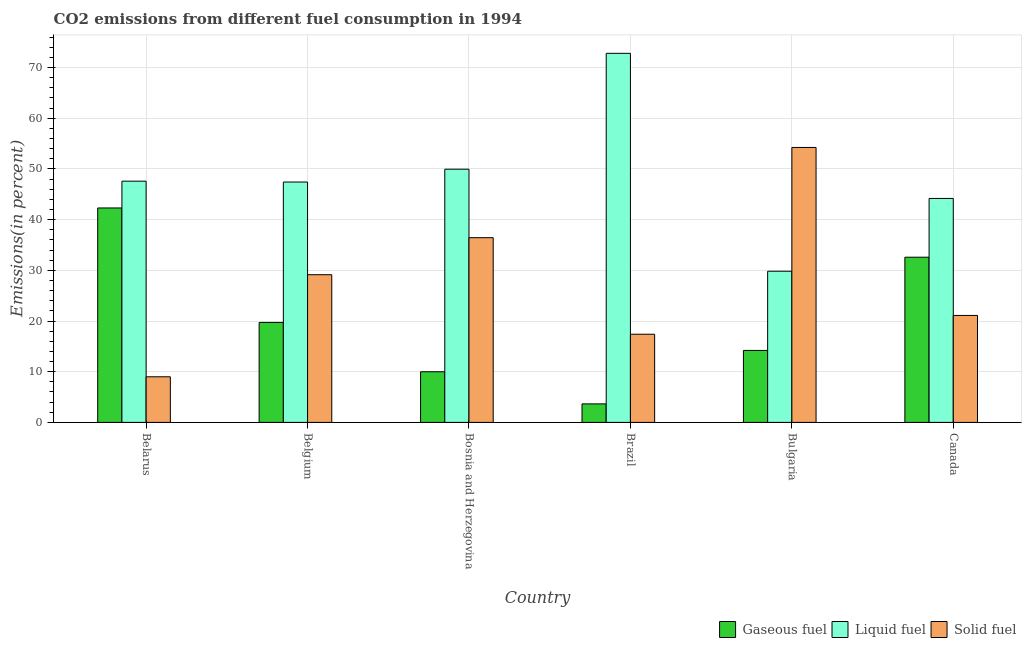How many groups of bars are there?
Provide a succinct answer. 6. Are the number of bars on each tick of the X-axis equal?
Your response must be concise. Yes. How many bars are there on the 3rd tick from the left?
Your response must be concise. 3. How many bars are there on the 3rd tick from the right?
Give a very brief answer. 3. What is the label of the 3rd group of bars from the left?
Offer a very short reply. Bosnia and Herzegovina. What is the percentage of liquid fuel emission in Bulgaria?
Give a very brief answer. 29.82. Across all countries, what is the maximum percentage of gaseous fuel emission?
Offer a terse response. 42.3. Across all countries, what is the minimum percentage of liquid fuel emission?
Provide a succinct answer. 29.82. In which country was the percentage of gaseous fuel emission maximum?
Offer a terse response. Belarus. In which country was the percentage of liquid fuel emission minimum?
Your answer should be compact. Bulgaria. What is the total percentage of solid fuel emission in the graph?
Your answer should be compact. 167.28. What is the difference between the percentage of solid fuel emission in Bulgaria and that in Canada?
Your answer should be very brief. 33.13. What is the difference between the percentage of gaseous fuel emission in Canada and the percentage of solid fuel emission in Bosnia and Herzegovina?
Your answer should be very brief. -3.85. What is the average percentage of gaseous fuel emission per country?
Offer a terse response. 20.41. What is the difference between the percentage of solid fuel emission and percentage of liquid fuel emission in Bulgaria?
Your response must be concise. 24.41. In how many countries, is the percentage of gaseous fuel emission greater than 36 %?
Ensure brevity in your answer.  1. What is the ratio of the percentage of liquid fuel emission in Belarus to that in Bulgaria?
Your response must be concise. 1.6. What is the difference between the highest and the second highest percentage of gaseous fuel emission?
Your response must be concise. 9.71. What is the difference between the highest and the lowest percentage of liquid fuel emission?
Your answer should be very brief. 42.98. What does the 3rd bar from the left in Belgium represents?
Ensure brevity in your answer.  Solid fuel. What does the 1st bar from the right in Bulgaria represents?
Make the answer very short. Solid fuel. How many bars are there?
Ensure brevity in your answer.  18. Are all the bars in the graph horizontal?
Provide a short and direct response. No. How many countries are there in the graph?
Keep it short and to the point. 6. What is the difference between two consecutive major ticks on the Y-axis?
Your answer should be very brief. 10. What is the title of the graph?
Your answer should be compact. CO2 emissions from different fuel consumption in 1994. What is the label or title of the X-axis?
Offer a terse response. Country. What is the label or title of the Y-axis?
Ensure brevity in your answer.  Emissions(in percent). What is the Emissions(in percent) of Gaseous fuel in Belarus?
Provide a short and direct response. 42.3. What is the Emissions(in percent) in Liquid fuel in Belarus?
Offer a very short reply. 47.58. What is the Emissions(in percent) in Solid fuel in Belarus?
Your answer should be compact. 9. What is the Emissions(in percent) of Gaseous fuel in Belgium?
Offer a terse response. 19.72. What is the Emissions(in percent) of Liquid fuel in Belgium?
Keep it short and to the point. 47.41. What is the Emissions(in percent) of Solid fuel in Belgium?
Ensure brevity in your answer.  29.13. What is the Emissions(in percent) in Gaseous fuel in Bosnia and Herzegovina?
Your response must be concise. 9.99. What is the Emissions(in percent) of Liquid fuel in Bosnia and Herzegovina?
Your answer should be very brief. 49.94. What is the Emissions(in percent) of Solid fuel in Bosnia and Herzegovina?
Provide a succinct answer. 36.44. What is the Emissions(in percent) of Gaseous fuel in Brazil?
Offer a very short reply. 3.65. What is the Emissions(in percent) in Liquid fuel in Brazil?
Make the answer very short. 72.8. What is the Emissions(in percent) in Solid fuel in Brazil?
Your response must be concise. 17.39. What is the Emissions(in percent) in Gaseous fuel in Bulgaria?
Your response must be concise. 14.2. What is the Emissions(in percent) of Liquid fuel in Bulgaria?
Give a very brief answer. 29.82. What is the Emissions(in percent) of Solid fuel in Bulgaria?
Ensure brevity in your answer.  54.23. What is the Emissions(in percent) of Gaseous fuel in Canada?
Offer a terse response. 32.58. What is the Emissions(in percent) of Liquid fuel in Canada?
Make the answer very short. 44.17. What is the Emissions(in percent) of Solid fuel in Canada?
Your response must be concise. 21.1. Across all countries, what is the maximum Emissions(in percent) in Gaseous fuel?
Provide a succinct answer. 42.3. Across all countries, what is the maximum Emissions(in percent) of Liquid fuel?
Ensure brevity in your answer.  72.8. Across all countries, what is the maximum Emissions(in percent) in Solid fuel?
Give a very brief answer. 54.23. Across all countries, what is the minimum Emissions(in percent) in Gaseous fuel?
Your answer should be compact. 3.65. Across all countries, what is the minimum Emissions(in percent) in Liquid fuel?
Offer a terse response. 29.82. Across all countries, what is the minimum Emissions(in percent) in Solid fuel?
Provide a short and direct response. 9. What is the total Emissions(in percent) in Gaseous fuel in the graph?
Your answer should be very brief. 122.44. What is the total Emissions(in percent) in Liquid fuel in the graph?
Offer a very short reply. 291.73. What is the total Emissions(in percent) in Solid fuel in the graph?
Offer a terse response. 167.28. What is the difference between the Emissions(in percent) of Gaseous fuel in Belarus and that in Belgium?
Your answer should be very brief. 22.58. What is the difference between the Emissions(in percent) of Liquid fuel in Belarus and that in Belgium?
Ensure brevity in your answer.  0.17. What is the difference between the Emissions(in percent) in Solid fuel in Belarus and that in Belgium?
Offer a very short reply. -20.14. What is the difference between the Emissions(in percent) in Gaseous fuel in Belarus and that in Bosnia and Herzegovina?
Offer a terse response. 32.31. What is the difference between the Emissions(in percent) of Liquid fuel in Belarus and that in Bosnia and Herzegovina?
Provide a short and direct response. -2.36. What is the difference between the Emissions(in percent) in Solid fuel in Belarus and that in Bosnia and Herzegovina?
Ensure brevity in your answer.  -27.44. What is the difference between the Emissions(in percent) of Gaseous fuel in Belarus and that in Brazil?
Your response must be concise. 38.65. What is the difference between the Emissions(in percent) of Liquid fuel in Belarus and that in Brazil?
Keep it short and to the point. -25.22. What is the difference between the Emissions(in percent) in Solid fuel in Belarus and that in Brazil?
Keep it short and to the point. -8.4. What is the difference between the Emissions(in percent) in Gaseous fuel in Belarus and that in Bulgaria?
Your answer should be compact. 28.1. What is the difference between the Emissions(in percent) of Liquid fuel in Belarus and that in Bulgaria?
Provide a short and direct response. 17.76. What is the difference between the Emissions(in percent) in Solid fuel in Belarus and that in Bulgaria?
Provide a succinct answer. -45.23. What is the difference between the Emissions(in percent) of Gaseous fuel in Belarus and that in Canada?
Keep it short and to the point. 9.71. What is the difference between the Emissions(in percent) in Liquid fuel in Belarus and that in Canada?
Ensure brevity in your answer.  3.41. What is the difference between the Emissions(in percent) of Solid fuel in Belarus and that in Canada?
Keep it short and to the point. -12.1. What is the difference between the Emissions(in percent) in Gaseous fuel in Belgium and that in Bosnia and Herzegovina?
Make the answer very short. 9.73. What is the difference between the Emissions(in percent) in Liquid fuel in Belgium and that in Bosnia and Herzegovina?
Provide a short and direct response. -2.53. What is the difference between the Emissions(in percent) in Solid fuel in Belgium and that in Bosnia and Herzegovina?
Keep it short and to the point. -7.3. What is the difference between the Emissions(in percent) of Gaseous fuel in Belgium and that in Brazil?
Your answer should be very brief. 16.07. What is the difference between the Emissions(in percent) of Liquid fuel in Belgium and that in Brazil?
Ensure brevity in your answer.  -25.39. What is the difference between the Emissions(in percent) in Solid fuel in Belgium and that in Brazil?
Offer a terse response. 11.74. What is the difference between the Emissions(in percent) of Gaseous fuel in Belgium and that in Bulgaria?
Your response must be concise. 5.52. What is the difference between the Emissions(in percent) of Liquid fuel in Belgium and that in Bulgaria?
Provide a short and direct response. 17.6. What is the difference between the Emissions(in percent) of Solid fuel in Belgium and that in Bulgaria?
Your answer should be very brief. -25.1. What is the difference between the Emissions(in percent) in Gaseous fuel in Belgium and that in Canada?
Offer a very short reply. -12.86. What is the difference between the Emissions(in percent) of Liquid fuel in Belgium and that in Canada?
Make the answer very short. 3.24. What is the difference between the Emissions(in percent) of Solid fuel in Belgium and that in Canada?
Ensure brevity in your answer.  8.03. What is the difference between the Emissions(in percent) of Gaseous fuel in Bosnia and Herzegovina and that in Brazil?
Your response must be concise. 6.34. What is the difference between the Emissions(in percent) in Liquid fuel in Bosnia and Herzegovina and that in Brazil?
Make the answer very short. -22.86. What is the difference between the Emissions(in percent) in Solid fuel in Bosnia and Herzegovina and that in Brazil?
Make the answer very short. 19.04. What is the difference between the Emissions(in percent) in Gaseous fuel in Bosnia and Herzegovina and that in Bulgaria?
Your answer should be compact. -4.21. What is the difference between the Emissions(in percent) of Liquid fuel in Bosnia and Herzegovina and that in Bulgaria?
Your answer should be compact. 20.13. What is the difference between the Emissions(in percent) in Solid fuel in Bosnia and Herzegovina and that in Bulgaria?
Your response must be concise. -17.79. What is the difference between the Emissions(in percent) in Gaseous fuel in Bosnia and Herzegovina and that in Canada?
Make the answer very short. -22.59. What is the difference between the Emissions(in percent) in Liquid fuel in Bosnia and Herzegovina and that in Canada?
Offer a very short reply. 5.77. What is the difference between the Emissions(in percent) in Solid fuel in Bosnia and Herzegovina and that in Canada?
Ensure brevity in your answer.  15.34. What is the difference between the Emissions(in percent) of Gaseous fuel in Brazil and that in Bulgaria?
Your answer should be very brief. -10.55. What is the difference between the Emissions(in percent) of Liquid fuel in Brazil and that in Bulgaria?
Offer a terse response. 42.98. What is the difference between the Emissions(in percent) in Solid fuel in Brazil and that in Bulgaria?
Offer a very short reply. -36.84. What is the difference between the Emissions(in percent) in Gaseous fuel in Brazil and that in Canada?
Ensure brevity in your answer.  -28.93. What is the difference between the Emissions(in percent) in Liquid fuel in Brazil and that in Canada?
Provide a succinct answer. 28.63. What is the difference between the Emissions(in percent) of Solid fuel in Brazil and that in Canada?
Your response must be concise. -3.71. What is the difference between the Emissions(in percent) in Gaseous fuel in Bulgaria and that in Canada?
Make the answer very short. -18.39. What is the difference between the Emissions(in percent) of Liquid fuel in Bulgaria and that in Canada?
Ensure brevity in your answer.  -14.36. What is the difference between the Emissions(in percent) of Solid fuel in Bulgaria and that in Canada?
Provide a succinct answer. 33.13. What is the difference between the Emissions(in percent) of Gaseous fuel in Belarus and the Emissions(in percent) of Liquid fuel in Belgium?
Keep it short and to the point. -5.12. What is the difference between the Emissions(in percent) of Gaseous fuel in Belarus and the Emissions(in percent) of Solid fuel in Belgium?
Offer a very short reply. 13.17. What is the difference between the Emissions(in percent) of Liquid fuel in Belarus and the Emissions(in percent) of Solid fuel in Belgium?
Your response must be concise. 18.45. What is the difference between the Emissions(in percent) of Gaseous fuel in Belarus and the Emissions(in percent) of Liquid fuel in Bosnia and Herzegovina?
Your response must be concise. -7.65. What is the difference between the Emissions(in percent) in Gaseous fuel in Belarus and the Emissions(in percent) in Solid fuel in Bosnia and Herzegovina?
Make the answer very short. 5.86. What is the difference between the Emissions(in percent) of Liquid fuel in Belarus and the Emissions(in percent) of Solid fuel in Bosnia and Herzegovina?
Offer a terse response. 11.15. What is the difference between the Emissions(in percent) in Gaseous fuel in Belarus and the Emissions(in percent) in Liquid fuel in Brazil?
Ensure brevity in your answer.  -30.5. What is the difference between the Emissions(in percent) in Gaseous fuel in Belarus and the Emissions(in percent) in Solid fuel in Brazil?
Provide a short and direct response. 24.91. What is the difference between the Emissions(in percent) of Liquid fuel in Belarus and the Emissions(in percent) of Solid fuel in Brazil?
Your answer should be very brief. 30.19. What is the difference between the Emissions(in percent) of Gaseous fuel in Belarus and the Emissions(in percent) of Liquid fuel in Bulgaria?
Make the answer very short. 12.48. What is the difference between the Emissions(in percent) of Gaseous fuel in Belarus and the Emissions(in percent) of Solid fuel in Bulgaria?
Your response must be concise. -11.93. What is the difference between the Emissions(in percent) of Liquid fuel in Belarus and the Emissions(in percent) of Solid fuel in Bulgaria?
Offer a very short reply. -6.65. What is the difference between the Emissions(in percent) in Gaseous fuel in Belarus and the Emissions(in percent) in Liquid fuel in Canada?
Keep it short and to the point. -1.88. What is the difference between the Emissions(in percent) of Gaseous fuel in Belarus and the Emissions(in percent) of Solid fuel in Canada?
Make the answer very short. 21.2. What is the difference between the Emissions(in percent) in Liquid fuel in Belarus and the Emissions(in percent) in Solid fuel in Canada?
Give a very brief answer. 26.49. What is the difference between the Emissions(in percent) in Gaseous fuel in Belgium and the Emissions(in percent) in Liquid fuel in Bosnia and Herzegovina?
Give a very brief answer. -30.22. What is the difference between the Emissions(in percent) of Gaseous fuel in Belgium and the Emissions(in percent) of Solid fuel in Bosnia and Herzegovina?
Keep it short and to the point. -16.72. What is the difference between the Emissions(in percent) of Liquid fuel in Belgium and the Emissions(in percent) of Solid fuel in Bosnia and Herzegovina?
Keep it short and to the point. 10.98. What is the difference between the Emissions(in percent) of Gaseous fuel in Belgium and the Emissions(in percent) of Liquid fuel in Brazil?
Provide a short and direct response. -53.08. What is the difference between the Emissions(in percent) of Gaseous fuel in Belgium and the Emissions(in percent) of Solid fuel in Brazil?
Your response must be concise. 2.33. What is the difference between the Emissions(in percent) in Liquid fuel in Belgium and the Emissions(in percent) in Solid fuel in Brazil?
Offer a terse response. 30.02. What is the difference between the Emissions(in percent) in Gaseous fuel in Belgium and the Emissions(in percent) in Liquid fuel in Bulgaria?
Make the answer very short. -10.1. What is the difference between the Emissions(in percent) in Gaseous fuel in Belgium and the Emissions(in percent) in Solid fuel in Bulgaria?
Your answer should be very brief. -34.51. What is the difference between the Emissions(in percent) of Liquid fuel in Belgium and the Emissions(in percent) of Solid fuel in Bulgaria?
Offer a terse response. -6.82. What is the difference between the Emissions(in percent) of Gaseous fuel in Belgium and the Emissions(in percent) of Liquid fuel in Canada?
Your answer should be very brief. -24.45. What is the difference between the Emissions(in percent) of Gaseous fuel in Belgium and the Emissions(in percent) of Solid fuel in Canada?
Keep it short and to the point. -1.38. What is the difference between the Emissions(in percent) of Liquid fuel in Belgium and the Emissions(in percent) of Solid fuel in Canada?
Keep it short and to the point. 26.32. What is the difference between the Emissions(in percent) of Gaseous fuel in Bosnia and Herzegovina and the Emissions(in percent) of Liquid fuel in Brazil?
Give a very brief answer. -62.81. What is the difference between the Emissions(in percent) of Gaseous fuel in Bosnia and Herzegovina and the Emissions(in percent) of Solid fuel in Brazil?
Your answer should be compact. -7.4. What is the difference between the Emissions(in percent) in Liquid fuel in Bosnia and Herzegovina and the Emissions(in percent) in Solid fuel in Brazil?
Make the answer very short. 32.55. What is the difference between the Emissions(in percent) of Gaseous fuel in Bosnia and Herzegovina and the Emissions(in percent) of Liquid fuel in Bulgaria?
Offer a very short reply. -19.83. What is the difference between the Emissions(in percent) of Gaseous fuel in Bosnia and Herzegovina and the Emissions(in percent) of Solid fuel in Bulgaria?
Provide a succinct answer. -44.24. What is the difference between the Emissions(in percent) in Liquid fuel in Bosnia and Herzegovina and the Emissions(in percent) in Solid fuel in Bulgaria?
Ensure brevity in your answer.  -4.29. What is the difference between the Emissions(in percent) in Gaseous fuel in Bosnia and Herzegovina and the Emissions(in percent) in Liquid fuel in Canada?
Keep it short and to the point. -34.19. What is the difference between the Emissions(in percent) of Gaseous fuel in Bosnia and Herzegovina and the Emissions(in percent) of Solid fuel in Canada?
Your response must be concise. -11.11. What is the difference between the Emissions(in percent) in Liquid fuel in Bosnia and Herzegovina and the Emissions(in percent) in Solid fuel in Canada?
Your answer should be compact. 28.85. What is the difference between the Emissions(in percent) of Gaseous fuel in Brazil and the Emissions(in percent) of Liquid fuel in Bulgaria?
Offer a very short reply. -26.17. What is the difference between the Emissions(in percent) in Gaseous fuel in Brazil and the Emissions(in percent) in Solid fuel in Bulgaria?
Your answer should be very brief. -50.58. What is the difference between the Emissions(in percent) in Liquid fuel in Brazil and the Emissions(in percent) in Solid fuel in Bulgaria?
Offer a terse response. 18.57. What is the difference between the Emissions(in percent) of Gaseous fuel in Brazil and the Emissions(in percent) of Liquid fuel in Canada?
Give a very brief answer. -40.52. What is the difference between the Emissions(in percent) of Gaseous fuel in Brazil and the Emissions(in percent) of Solid fuel in Canada?
Offer a very short reply. -17.45. What is the difference between the Emissions(in percent) of Liquid fuel in Brazil and the Emissions(in percent) of Solid fuel in Canada?
Provide a succinct answer. 51.7. What is the difference between the Emissions(in percent) of Gaseous fuel in Bulgaria and the Emissions(in percent) of Liquid fuel in Canada?
Ensure brevity in your answer.  -29.98. What is the difference between the Emissions(in percent) in Gaseous fuel in Bulgaria and the Emissions(in percent) in Solid fuel in Canada?
Offer a very short reply. -6.9. What is the difference between the Emissions(in percent) of Liquid fuel in Bulgaria and the Emissions(in percent) of Solid fuel in Canada?
Provide a short and direct response. 8.72. What is the average Emissions(in percent) of Gaseous fuel per country?
Give a very brief answer. 20.41. What is the average Emissions(in percent) in Liquid fuel per country?
Your answer should be very brief. 48.62. What is the average Emissions(in percent) in Solid fuel per country?
Ensure brevity in your answer.  27.88. What is the difference between the Emissions(in percent) in Gaseous fuel and Emissions(in percent) in Liquid fuel in Belarus?
Your response must be concise. -5.29. What is the difference between the Emissions(in percent) in Gaseous fuel and Emissions(in percent) in Solid fuel in Belarus?
Offer a very short reply. 33.3. What is the difference between the Emissions(in percent) in Liquid fuel and Emissions(in percent) in Solid fuel in Belarus?
Offer a very short reply. 38.59. What is the difference between the Emissions(in percent) of Gaseous fuel and Emissions(in percent) of Liquid fuel in Belgium?
Give a very brief answer. -27.69. What is the difference between the Emissions(in percent) of Gaseous fuel and Emissions(in percent) of Solid fuel in Belgium?
Provide a short and direct response. -9.41. What is the difference between the Emissions(in percent) of Liquid fuel and Emissions(in percent) of Solid fuel in Belgium?
Offer a very short reply. 18.28. What is the difference between the Emissions(in percent) in Gaseous fuel and Emissions(in percent) in Liquid fuel in Bosnia and Herzegovina?
Your response must be concise. -39.95. What is the difference between the Emissions(in percent) of Gaseous fuel and Emissions(in percent) of Solid fuel in Bosnia and Herzegovina?
Provide a short and direct response. -26.45. What is the difference between the Emissions(in percent) of Liquid fuel and Emissions(in percent) of Solid fuel in Bosnia and Herzegovina?
Offer a very short reply. 13.51. What is the difference between the Emissions(in percent) in Gaseous fuel and Emissions(in percent) in Liquid fuel in Brazil?
Provide a succinct answer. -69.15. What is the difference between the Emissions(in percent) of Gaseous fuel and Emissions(in percent) of Solid fuel in Brazil?
Offer a very short reply. -13.74. What is the difference between the Emissions(in percent) in Liquid fuel and Emissions(in percent) in Solid fuel in Brazil?
Your answer should be very brief. 55.41. What is the difference between the Emissions(in percent) of Gaseous fuel and Emissions(in percent) of Liquid fuel in Bulgaria?
Provide a short and direct response. -15.62. What is the difference between the Emissions(in percent) in Gaseous fuel and Emissions(in percent) in Solid fuel in Bulgaria?
Give a very brief answer. -40.03. What is the difference between the Emissions(in percent) in Liquid fuel and Emissions(in percent) in Solid fuel in Bulgaria?
Your response must be concise. -24.41. What is the difference between the Emissions(in percent) of Gaseous fuel and Emissions(in percent) of Liquid fuel in Canada?
Ensure brevity in your answer.  -11.59. What is the difference between the Emissions(in percent) of Gaseous fuel and Emissions(in percent) of Solid fuel in Canada?
Your response must be concise. 11.49. What is the difference between the Emissions(in percent) in Liquid fuel and Emissions(in percent) in Solid fuel in Canada?
Offer a very short reply. 23.08. What is the ratio of the Emissions(in percent) of Gaseous fuel in Belarus to that in Belgium?
Your answer should be compact. 2.14. What is the ratio of the Emissions(in percent) in Liquid fuel in Belarus to that in Belgium?
Ensure brevity in your answer.  1. What is the ratio of the Emissions(in percent) of Solid fuel in Belarus to that in Belgium?
Your answer should be very brief. 0.31. What is the ratio of the Emissions(in percent) of Gaseous fuel in Belarus to that in Bosnia and Herzegovina?
Your answer should be compact. 4.23. What is the ratio of the Emissions(in percent) of Liquid fuel in Belarus to that in Bosnia and Herzegovina?
Make the answer very short. 0.95. What is the ratio of the Emissions(in percent) in Solid fuel in Belarus to that in Bosnia and Herzegovina?
Give a very brief answer. 0.25. What is the ratio of the Emissions(in percent) in Gaseous fuel in Belarus to that in Brazil?
Your answer should be compact. 11.59. What is the ratio of the Emissions(in percent) in Liquid fuel in Belarus to that in Brazil?
Provide a short and direct response. 0.65. What is the ratio of the Emissions(in percent) of Solid fuel in Belarus to that in Brazil?
Your answer should be very brief. 0.52. What is the ratio of the Emissions(in percent) in Gaseous fuel in Belarus to that in Bulgaria?
Offer a very short reply. 2.98. What is the ratio of the Emissions(in percent) of Liquid fuel in Belarus to that in Bulgaria?
Your answer should be very brief. 1.6. What is the ratio of the Emissions(in percent) in Solid fuel in Belarus to that in Bulgaria?
Your answer should be compact. 0.17. What is the ratio of the Emissions(in percent) in Gaseous fuel in Belarus to that in Canada?
Give a very brief answer. 1.3. What is the ratio of the Emissions(in percent) in Liquid fuel in Belarus to that in Canada?
Offer a terse response. 1.08. What is the ratio of the Emissions(in percent) in Solid fuel in Belarus to that in Canada?
Your answer should be very brief. 0.43. What is the ratio of the Emissions(in percent) of Gaseous fuel in Belgium to that in Bosnia and Herzegovina?
Make the answer very short. 1.97. What is the ratio of the Emissions(in percent) in Liquid fuel in Belgium to that in Bosnia and Herzegovina?
Offer a terse response. 0.95. What is the ratio of the Emissions(in percent) of Solid fuel in Belgium to that in Bosnia and Herzegovina?
Ensure brevity in your answer.  0.8. What is the ratio of the Emissions(in percent) in Gaseous fuel in Belgium to that in Brazil?
Your response must be concise. 5.4. What is the ratio of the Emissions(in percent) of Liquid fuel in Belgium to that in Brazil?
Offer a terse response. 0.65. What is the ratio of the Emissions(in percent) of Solid fuel in Belgium to that in Brazil?
Keep it short and to the point. 1.68. What is the ratio of the Emissions(in percent) of Gaseous fuel in Belgium to that in Bulgaria?
Provide a succinct answer. 1.39. What is the ratio of the Emissions(in percent) of Liquid fuel in Belgium to that in Bulgaria?
Give a very brief answer. 1.59. What is the ratio of the Emissions(in percent) of Solid fuel in Belgium to that in Bulgaria?
Ensure brevity in your answer.  0.54. What is the ratio of the Emissions(in percent) in Gaseous fuel in Belgium to that in Canada?
Offer a very short reply. 0.61. What is the ratio of the Emissions(in percent) in Liquid fuel in Belgium to that in Canada?
Offer a terse response. 1.07. What is the ratio of the Emissions(in percent) of Solid fuel in Belgium to that in Canada?
Your answer should be compact. 1.38. What is the ratio of the Emissions(in percent) of Gaseous fuel in Bosnia and Herzegovina to that in Brazil?
Provide a succinct answer. 2.74. What is the ratio of the Emissions(in percent) of Liquid fuel in Bosnia and Herzegovina to that in Brazil?
Keep it short and to the point. 0.69. What is the ratio of the Emissions(in percent) in Solid fuel in Bosnia and Herzegovina to that in Brazil?
Your answer should be very brief. 2.1. What is the ratio of the Emissions(in percent) in Gaseous fuel in Bosnia and Herzegovina to that in Bulgaria?
Keep it short and to the point. 0.7. What is the ratio of the Emissions(in percent) of Liquid fuel in Bosnia and Herzegovina to that in Bulgaria?
Provide a succinct answer. 1.67. What is the ratio of the Emissions(in percent) of Solid fuel in Bosnia and Herzegovina to that in Bulgaria?
Keep it short and to the point. 0.67. What is the ratio of the Emissions(in percent) of Gaseous fuel in Bosnia and Herzegovina to that in Canada?
Your response must be concise. 0.31. What is the ratio of the Emissions(in percent) of Liquid fuel in Bosnia and Herzegovina to that in Canada?
Offer a very short reply. 1.13. What is the ratio of the Emissions(in percent) in Solid fuel in Bosnia and Herzegovina to that in Canada?
Your answer should be compact. 1.73. What is the ratio of the Emissions(in percent) in Gaseous fuel in Brazil to that in Bulgaria?
Your response must be concise. 0.26. What is the ratio of the Emissions(in percent) in Liquid fuel in Brazil to that in Bulgaria?
Provide a succinct answer. 2.44. What is the ratio of the Emissions(in percent) in Solid fuel in Brazil to that in Bulgaria?
Offer a very short reply. 0.32. What is the ratio of the Emissions(in percent) in Gaseous fuel in Brazil to that in Canada?
Offer a terse response. 0.11. What is the ratio of the Emissions(in percent) in Liquid fuel in Brazil to that in Canada?
Make the answer very short. 1.65. What is the ratio of the Emissions(in percent) of Solid fuel in Brazil to that in Canada?
Offer a terse response. 0.82. What is the ratio of the Emissions(in percent) in Gaseous fuel in Bulgaria to that in Canada?
Provide a succinct answer. 0.44. What is the ratio of the Emissions(in percent) of Liquid fuel in Bulgaria to that in Canada?
Your answer should be very brief. 0.68. What is the ratio of the Emissions(in percent) of Solid fuel in Bulgaria to that in Canada?
Make the answer very short. 2.57. What is the difference between the highest and the second highest Emissions(in percent) of Gaseous fuel?
Keep it short and to the point. 9.71. What is the difference between the highest and the second highest Emissions(in percent) in Liquid fuel?
Provide a short and direct response. 22.86. What is the difference between the highest and the second highest Emissions(in percent) in Solid fuel?
Your answer should be very brief. 17.79. What is the difference between the highest and the lowest Emissions(in percent) in Gaseous fuel?
Provide a succinct answer. 38.65. What is the difference between the highest and the lowest Emissions(in percent) in Liquid fuel?
Give a very brief answer. 42.98. What is the difference between the highest and the lowest Emissions(in percent) of Solid fuel?
Your answer should be compact. 45.23. 